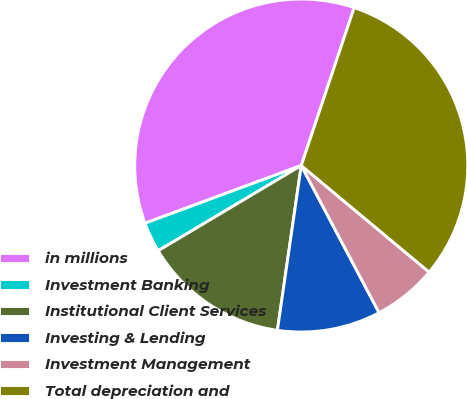<chart> <loc_0><loc_0><loc_500><loc_500><pie_chart><fcel>in millions<fcel>Investment Banking<fcel>Institutional Client Services<fcel>Investing & Lending<fcel>Investment Management<fcel>Total depreciation and<nl><fcel>35.78%<fcel>2.92%<fcel>14.16%<fcel>10.03%<fcel>6.2%<fcel>30.91%<nl></chart> 